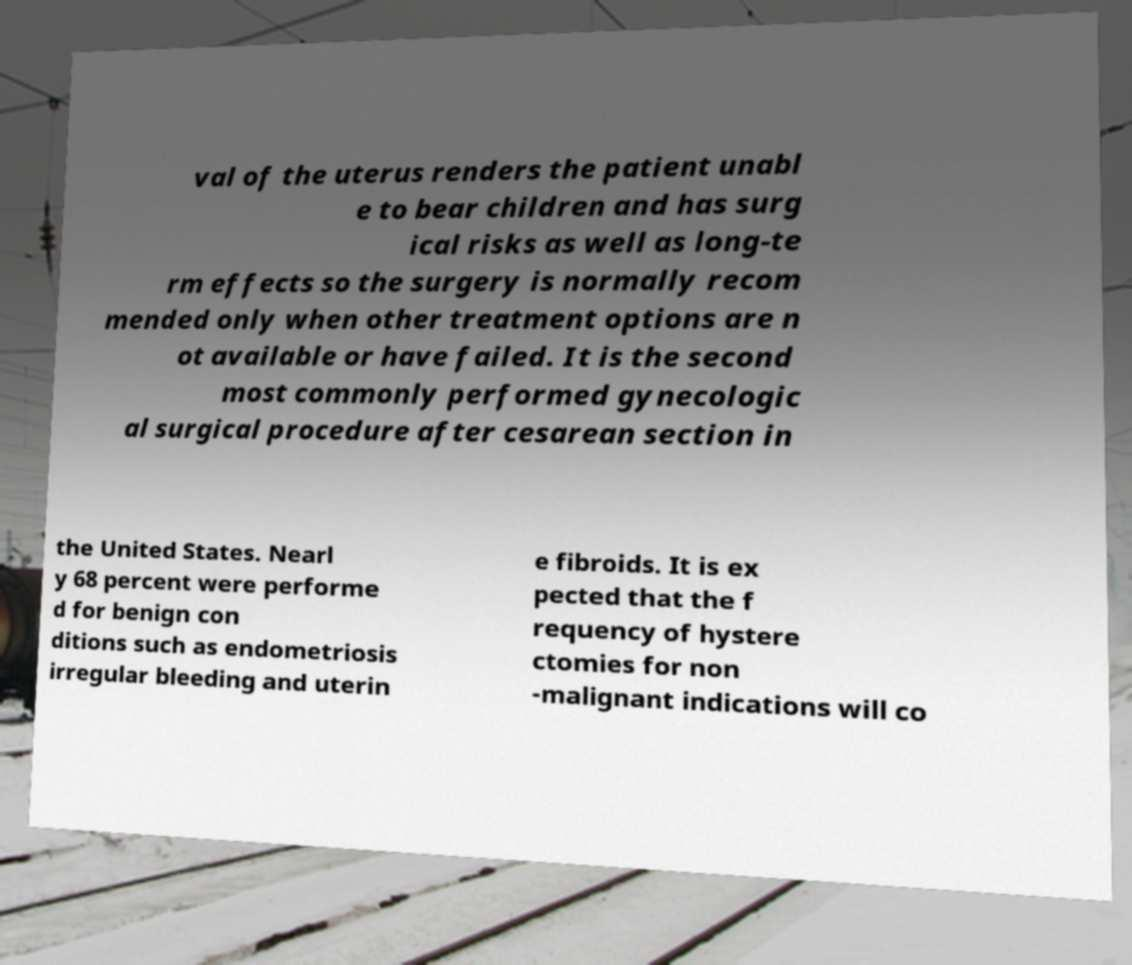Please read and relay the text visible in this image. What does it say? val of the uterus renders the patient unabl e to bear children and has surg ical risks as well as long-te rm effects so the surgery is normally recom mended only when other treatment options are n ot available or have failed. It is the second most commonly performed gynecologic al surgical procedure after cesarean section in the United States. Nearl y 68 percent were performe d for benign con ditions such as endometriosis irregular bleeding and uterin e fibroids. It is ex pected that the f requency of hystere ctomies for non -malignant indications will co 